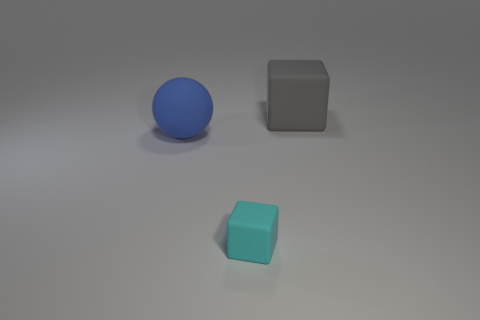Add 1 big green shiny cubes. How many objects exist? 4 Subtract all balls. How many objects are left? 2 Subtract 0 cyan cylinders. How many objects are left? 3 Subtract all tiny red balls. Subtract all big matte cubes. How many objects are left? 2 Add 1 tiny rubber cubes. How many tiny rubber cubes are left? 2 Add 3 tiny purple metallic cylinders. How many tiny purple metallic cylinders exist? 3 